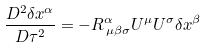<formula> <loc_0><loc_0><loc_500><loc_500>\frac { D ^ { 2 } \delta x ^ { \alpha } } { D \tau ^ { 2 } } = - R _ { \, \mu \beta \sigma } ^ { \alpha } U ^ { \mu } U ^ { \sigma } \delta x ^ { \beta }</formula> 